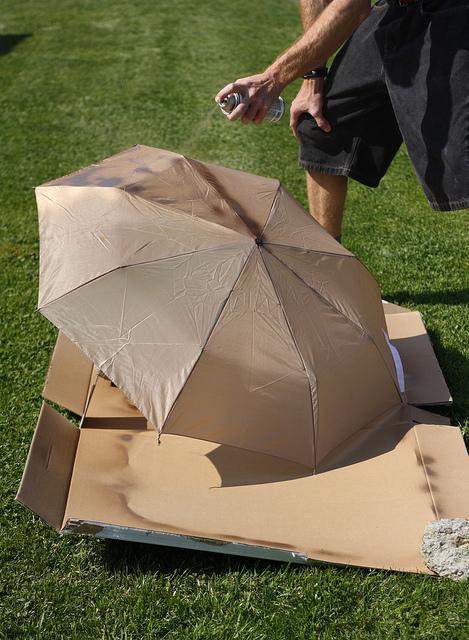What is being sprayed?
Keep it brief. Umbrella. Why did the person put cardboard underneath the umbrella?
Be succinct. To paint it. What color are the persons shorts?
Answer briefly. Black. What color is the umbrella?
Quick response, please. Brown. 